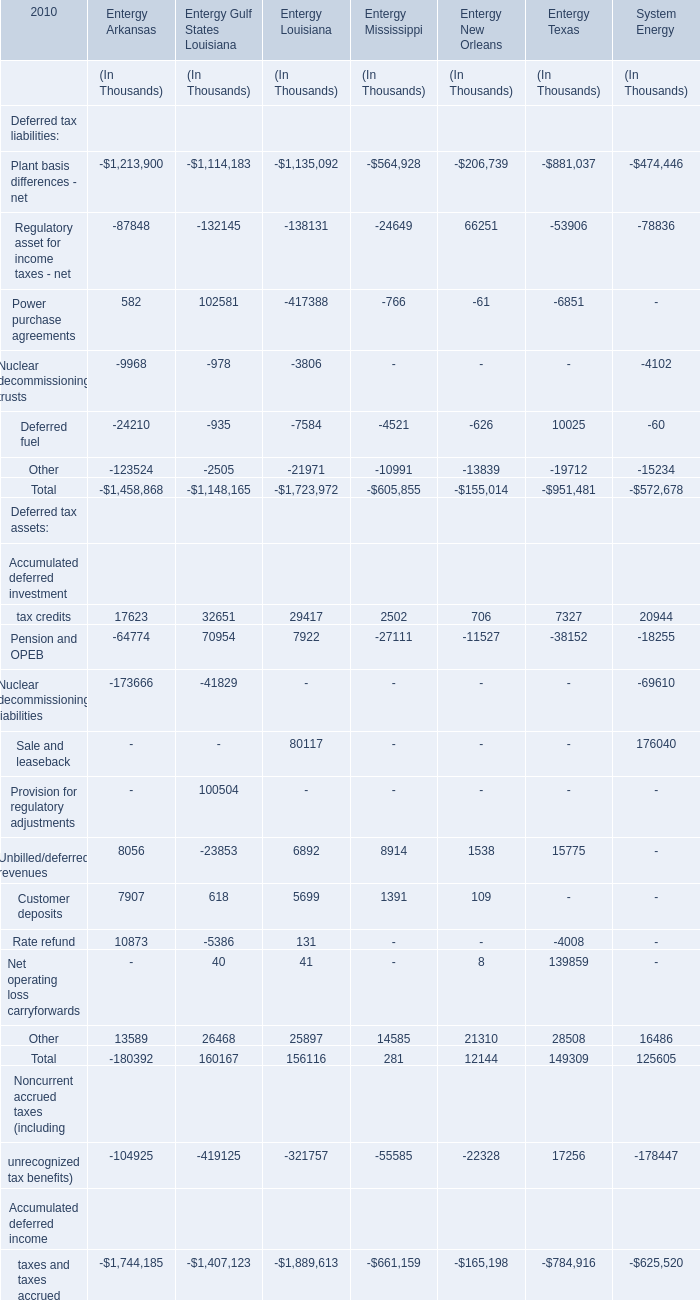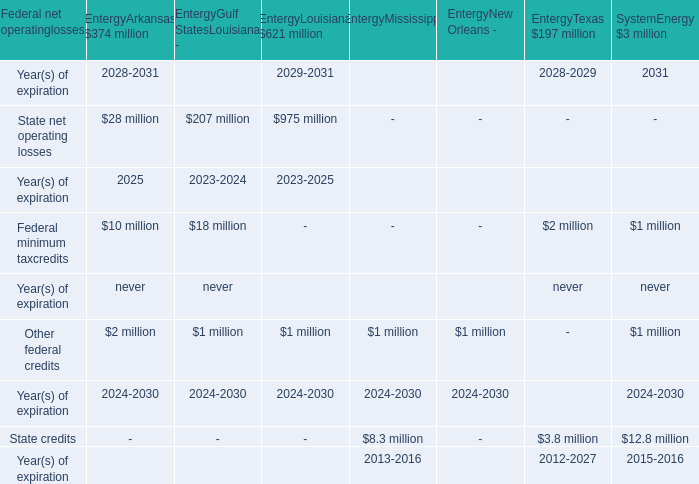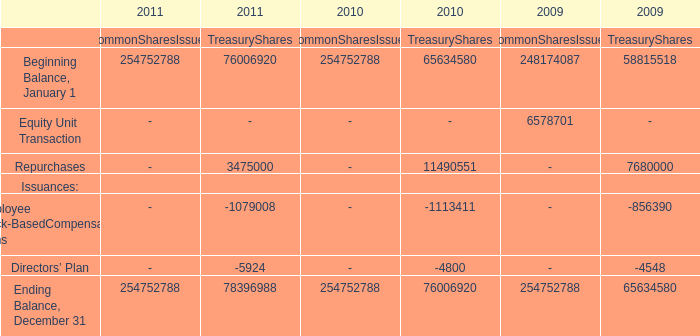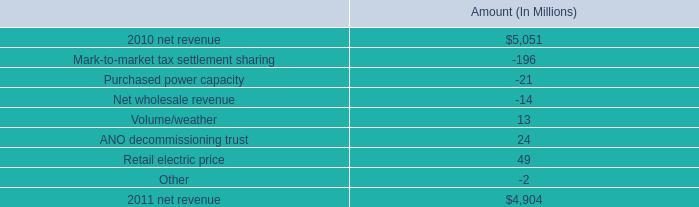what is the percentage change in net revenue from 2010 to 2011? 
Computations: ((4904 - 5051) / 5051)
Answer: -0.0291. 